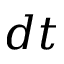<formula> <loc_0><loc_0><loc_500><loc_500>d t</formula> 